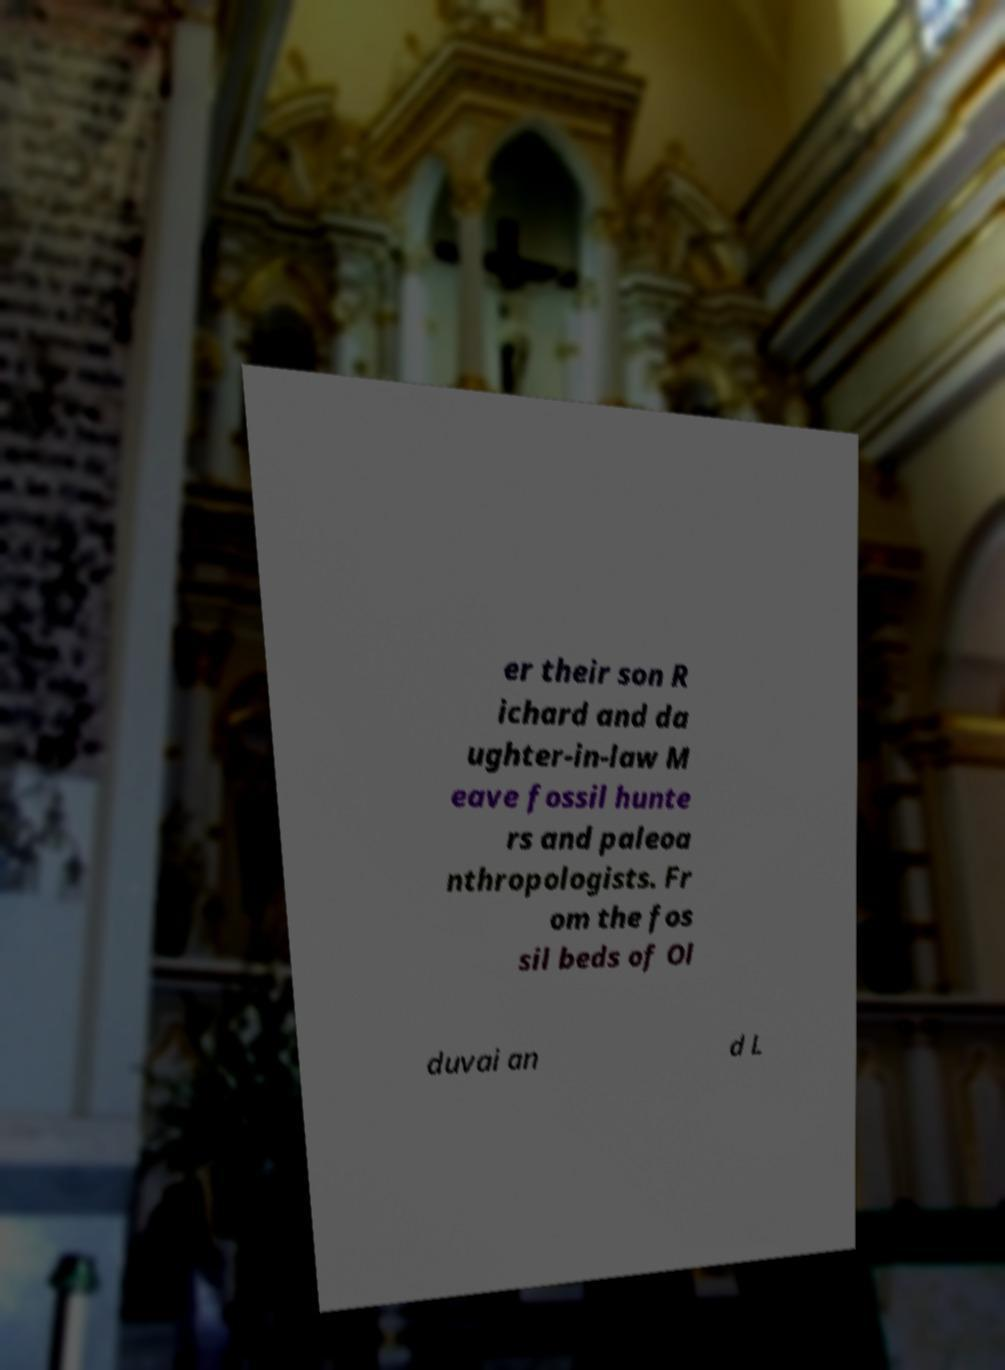What messages or text are displayed in this image? I need them in a readable, typed format. er their son R ichard and da ughter-in-law M eave fossil hunte rs and paleoa nthropologists. Fr om the fos sil beds of Ol duvai an d L 